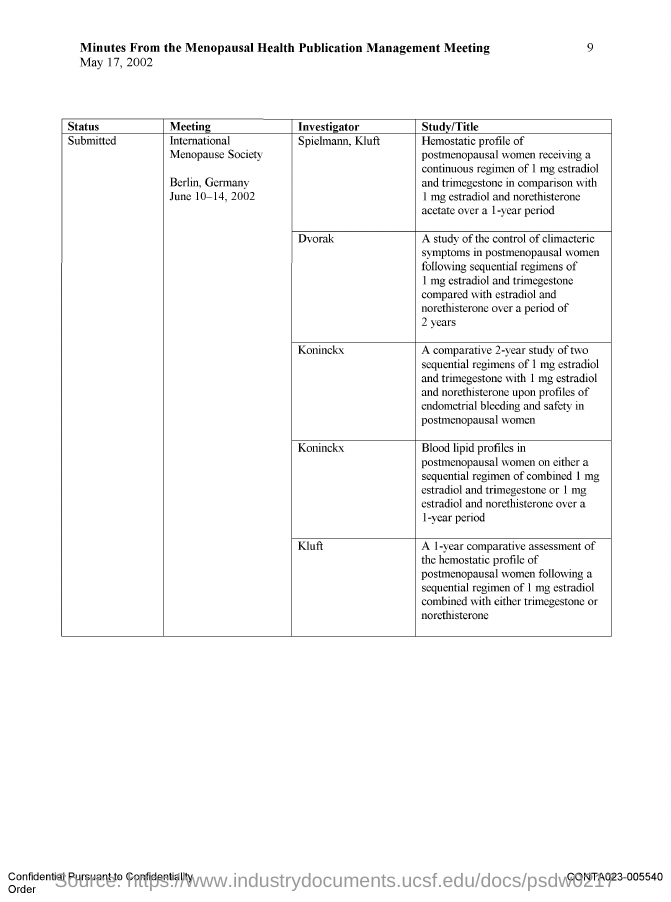Specify some key components in this picture. The International Menopause Society Meeting is scheduled to take place from June 10th to 14th, 2002. Koninckx is an investigator of the International Menopause Society. Dvorak is an investigator of the International Menopause Society meeting. The date on the document is May 17, 2002. The International Menopause Society is holding its meeting in Berlin, Germany. 